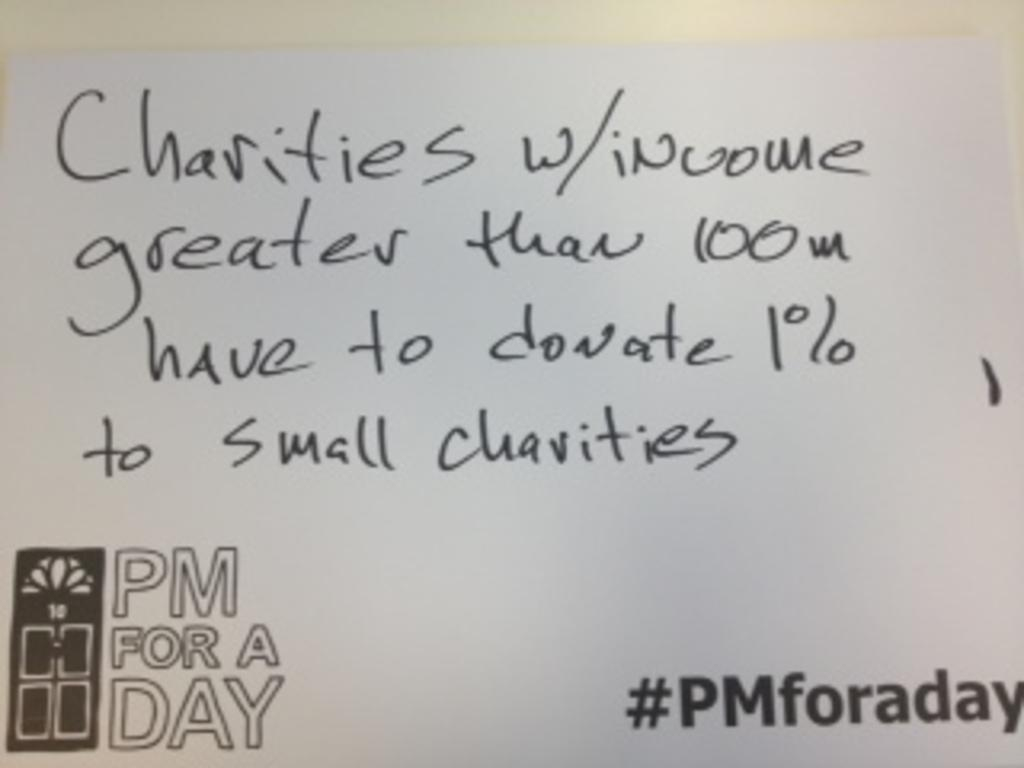<image>
Offer a succinct explanation of the picture presented. A paper the says "PM for a Day" has a message written on it about charities. 